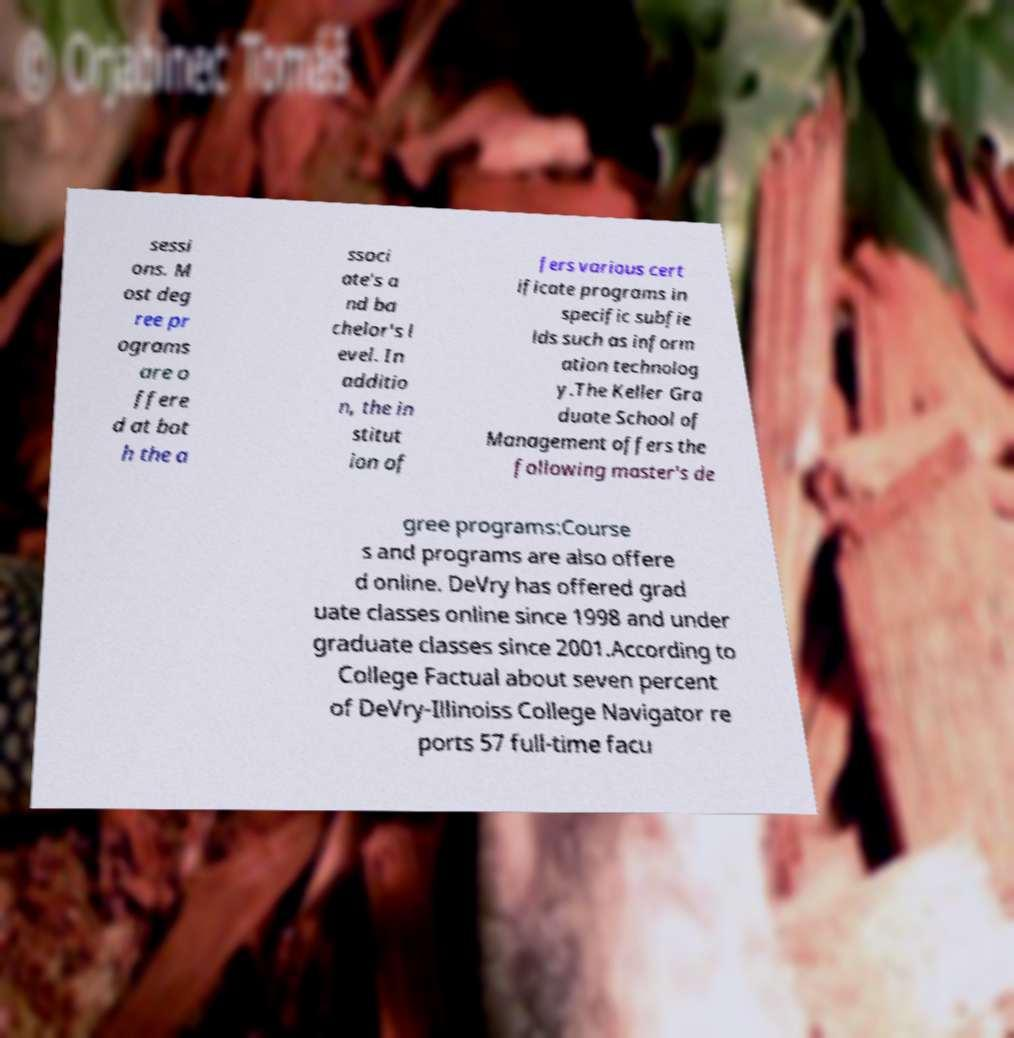Please identify and transcribe the text found in this image. sessi ons. M ost deg ree pr ograms are o ffere d at bot h the a ssoci ate's a nd ba chelor's l evel. In additio n, the in stitut ion of fers various cert ificate programs in specific subfie lds such as inform ation technolog y.The Keller Gra duate School of Management offers the following master's de gree programs:Course s and programs are also offere d online. DeVry has offered grad uate classes online since 1998 and under graduate classes since 2001.According to College Factual about seven percent of DeVry-Illinoiss College Navigator re ports 57 full-time facu 